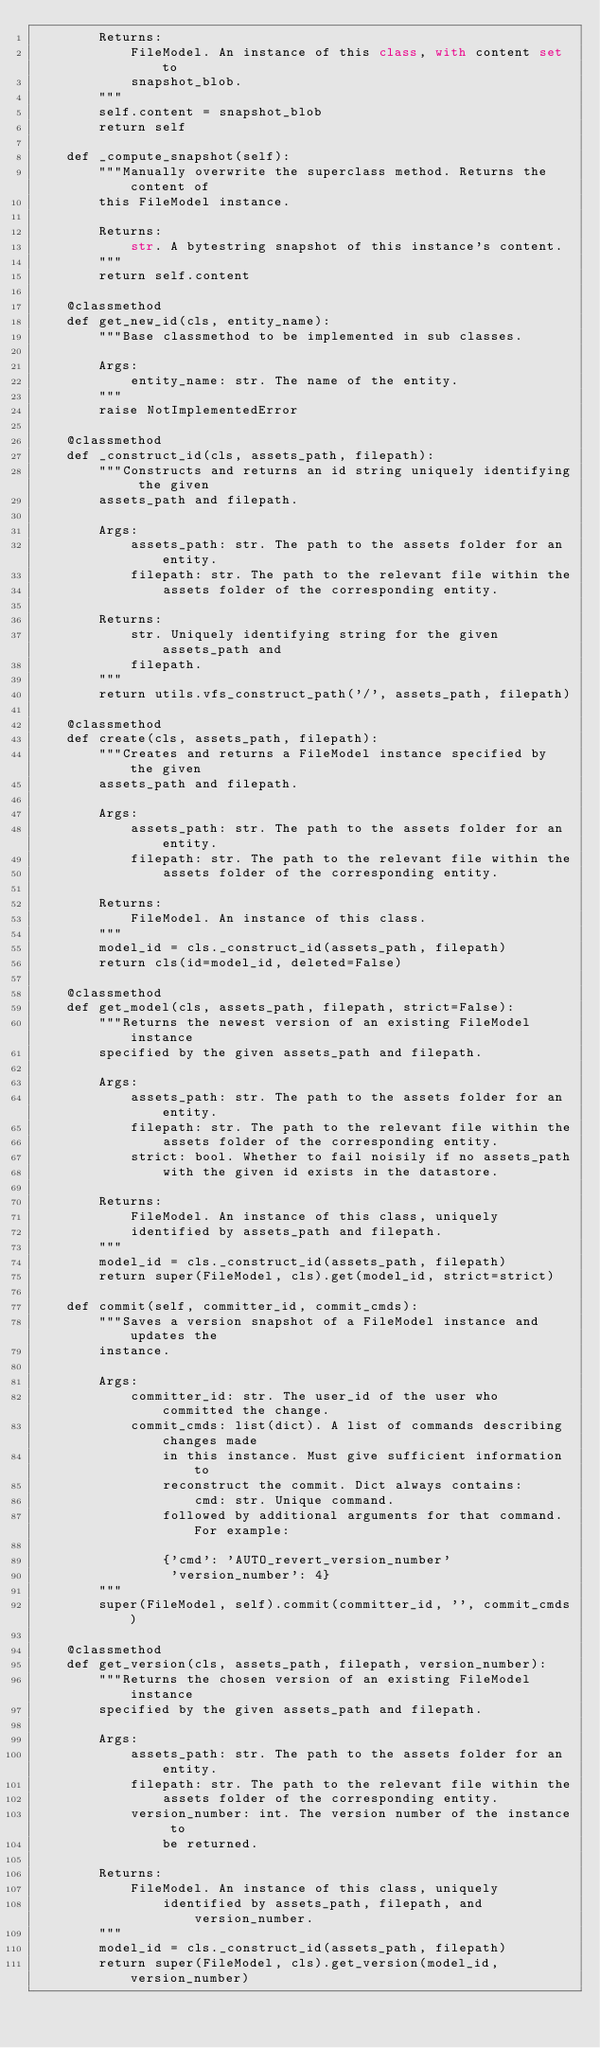<code> <loc_0><loc_0><loc_500><loc_500><_Python_>        Returns:
            FileModel. An instance of this class, with content set to
            snapshot_blob.
        """
        self.content = snapshot_blob
        return self

    def _compute_snapshot(self):
        """Manually overwrite the superclass method. Returns the content of
        this FileModel instance.

        Returns:
            str. A bytestring snapshot of this instance's content.
        """
        return self.content

    @classmethod
    def get_new_id(cls, entity_name):
        """Base classmethod to be implemented in sub classes.

        Args:
            entity_name: str. The name of the entity.
        """
        raise NotImplementedError

    @classmethod
    def _construct_id(cls, assets_path, filepath):
        """Constructs and returns an id string uniquely identifying the given
        assets_path and filepath.

        Args:
            assets_path: str. The path to the assets folder for an entity.
            filepath: str. The path to the relevant file within the
                assets folder of the corresponding entity.

        Returns:
            str. Uniquely identifying string for the given assets_path and
            filepath.
        """
        return utils.vfs_construct_path('/', assets_path, filepath)

    @classmethod
    def create(cls, assets_path, filepath):
        """Creates and returns a FileModel instance specified by the given
        assets_path and filepath.

        Args:
            assets_path: str. The path to the assets folder for an entity.
            filepath: str. The path to the relevant file within the
                assets folder of the corresponding entity.

        Returns:
            FileModel. An instance of this class.
        """
        model_id = cls._construct_id(assets_path, filepath)
        return cls(id=model_id, deleted=False)

    @classmethod
    def get_model(cls, assets_path, filepath, strict=False):
        """Returns the newest version of an existing FileModel instance
        specified by the given assets_path and filepath.

        Args:
            assets_path: str. The path to the assets folder for an entity.
            filepath: str. The path to the relevant file within the
                assets folder of the corresponding entity.
            strict: bool. Whether to fail noisily if no assets_path
                with the given id exists in the datastore.

        Returns:
            FileModel. An instance of this class, uniquely
            identified by assets_path and filepath.
        """
        model_id = cls._construct_id(assets_path, filepath)
        return super(FileModel, cls).get(model_id, strict=strict)

    def commit(self, committer_id, commit_cmds):
        """Saves a version snapshot of a FileModel instance and updates the
        instance.

        Args:
            committer_id: str. The user_id of the user who committed the change.
            commit_cmds: list(dict). A list of commands describing changes made
                in this instance. Must give sufficient information to
                reconstruct the commit. Dict always contains:
                    cmd: str. Unique command.
                followed by additional arguments for that command. For example:

                {'cmd': 'AUTO_revert_version_number'
                 'version_number': 4}
        """
        super(FileModel, self).commit(committer_id, '', commit_cmds)

    @classmethod
    def get_version(cls, assets_path, filepath, version_number):
        """Returns the chosen version of an existing FileModel instance
        specified by the given assets_path and filepath.

        Args:
            assets_path: str. The path to the assets folder for an entity.
            filepath: str. The path to the relevant file within the
                assets folder of the corresponding entity.
            version_number: int. The version number of the instance to
                be returned.

        Returns:
            FileModel. An instance of this class, uniquely
                identified by assets_path, filepath, and version_number.
        """
        model_id = cls._construct_id(assets_path, filepath)
        return super(FileModel, cls).get_version(model_id, version_number)
</code> 